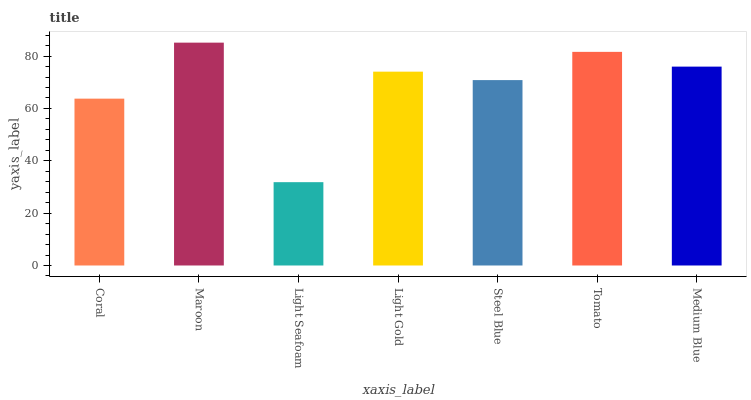Is Light Seafoam the minimum?
Answer yes or no. Yes. Is Maroon the maximum?
Answer yes or no. Yes. Is Maroon the minimum?
Answer yes or no. No. Is Light Seafoam the maximum?
Answer yes or no. No. Is Maroon greater than Light Seafoam?
Answer yes or no. Yes. Is Light Seafoam less than Maroon?
Answer yes or no. Yes. Is Light Seafoam greater than Maroon?
Answer yes or no. No. Is Maroon less than Light Seafoam?
Answer yes or no. No. Is Light Gold the high median?
Answer yes or no. Yes. Is Light Gold the low median?
Answer yes or no. Yes. Is Medium Blue the high median?
Answer yes or no. No. Is Steel Blue the low median?
Answer yes or no. No. 